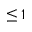Convert formula to latex. <formula><loc_0><loc_0><loc_500><loc_500>\leq 1</formula> 